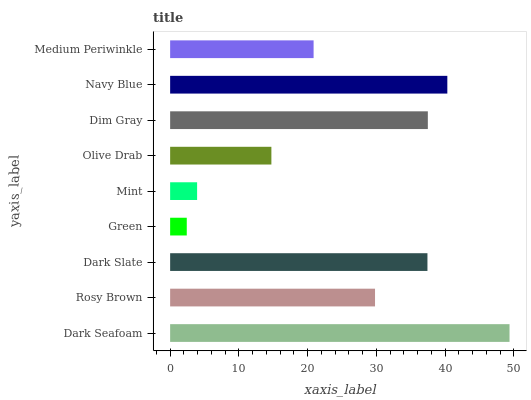Is Green the minimum?
Answer yes or no. Yes. Is Dark Seafoam the maximum?
Answer yes or no. Yes. Is Rosy Brown the minimum?
Answer yes or no. No. Is Rosy Brown the maximum?
Answer yes or no. No. Is Dark Seafoam greater than Rosy Brown?
Answer yes or no. Yes. Is Rosy Brown less than Dark Seafoam?
Answer yes or no. Yes. Is Rosy Brown greater than Dark Seafoam?
Answer yes or no. No. Is Dark Seafoam less than Rosy Brown?
Answer yes or no. No. Is Rosy Brown the high median?
Answer yes or no. Yes. Is Rosy Brown the low median?
Answer yes or no. Yes. Is Dark Seafoam the high median?
Answer yes or no. No. Is Medium Periwinkle the low median?
Answer yes or no. No. 